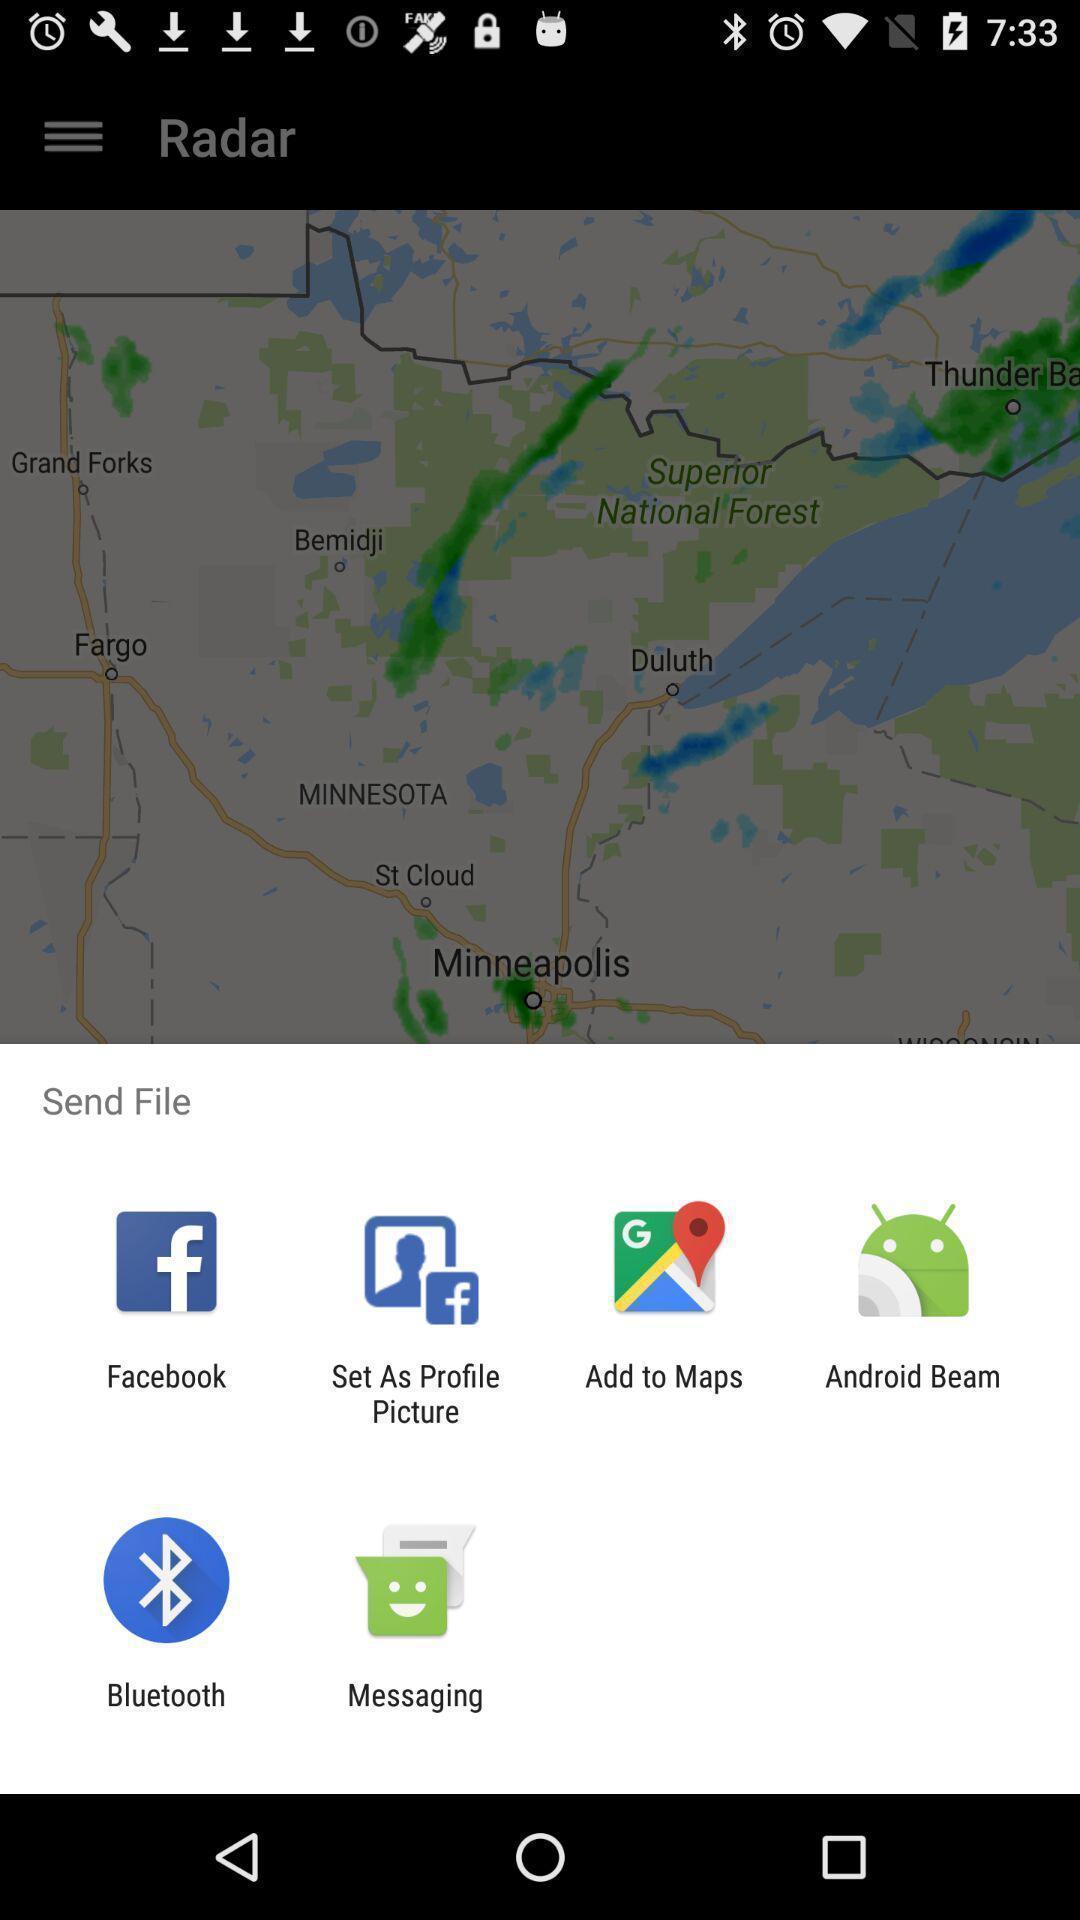What can you discern from this picture? Pop-up shows send option with multiple applications. 